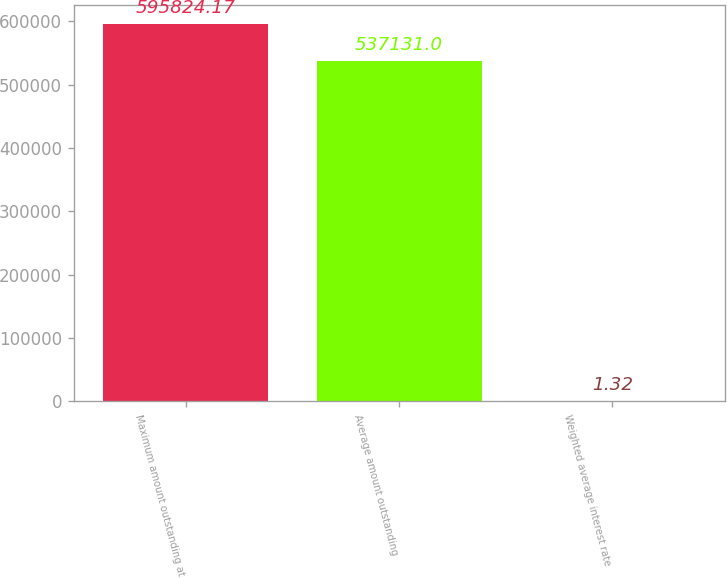Convert chart to OTSL. <chart><loc_0><loc_0><loc_500><loc_500><bar_chart><fcel>Maximum amount outstanding at<fcel>Average amount outstanding<fcel>Weighted average interest rate<nl><fcel>595824<fcel>537131<fcel>1.32<nl></chart> 